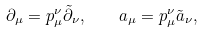<formula> <loc_0><loc_0><loc_500><loc_500>\partial _ { \mu } = p ^ { \nu } _ { \mu } \tilde { \partial } _ { \nu } , \quad a _ { \mu } = p ^ { \nu } _ { \mu } \tilde { a } _ { \nu } ,</formula> 